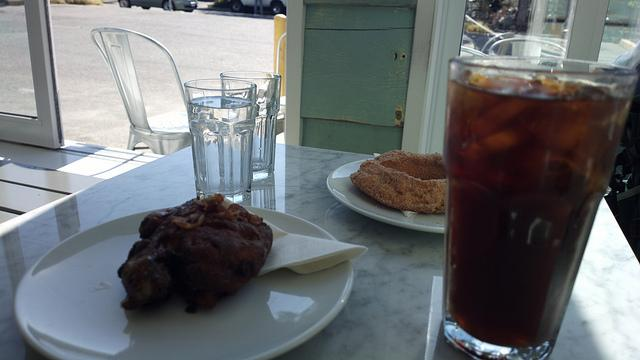Which object would have the least amount of flavors in it? water 